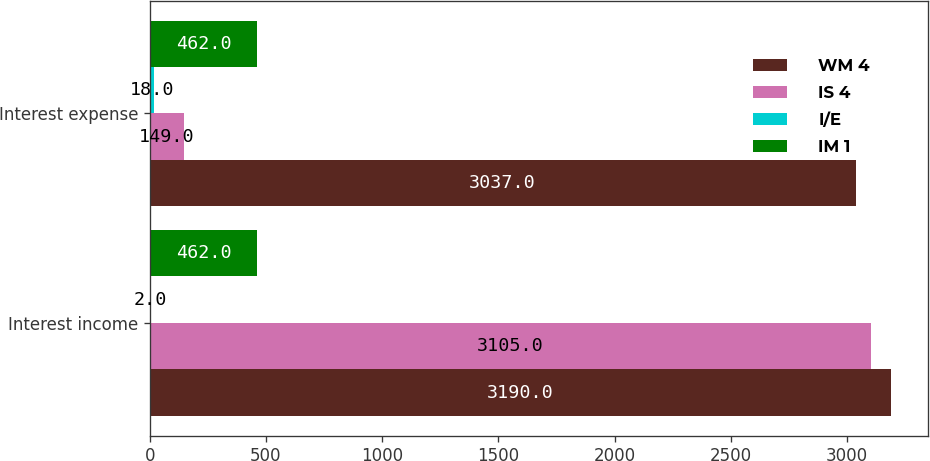Convert chart to OTSL. <chart><loc_0><loc_0><loc_500><loc_500><stacked_bar_chart><ecel><fcel>Interest income<fcel>Interest expense<nl><fcel>WM 4<fcel>3190<fcel>3037<nl><fcel>IS 4<fcel>3105<fcel>149<nl><fcel>I/E<fcel>2<fcel>18<nl><fcel>IM 1<fcel>462<fcel>462<nl></chart> 